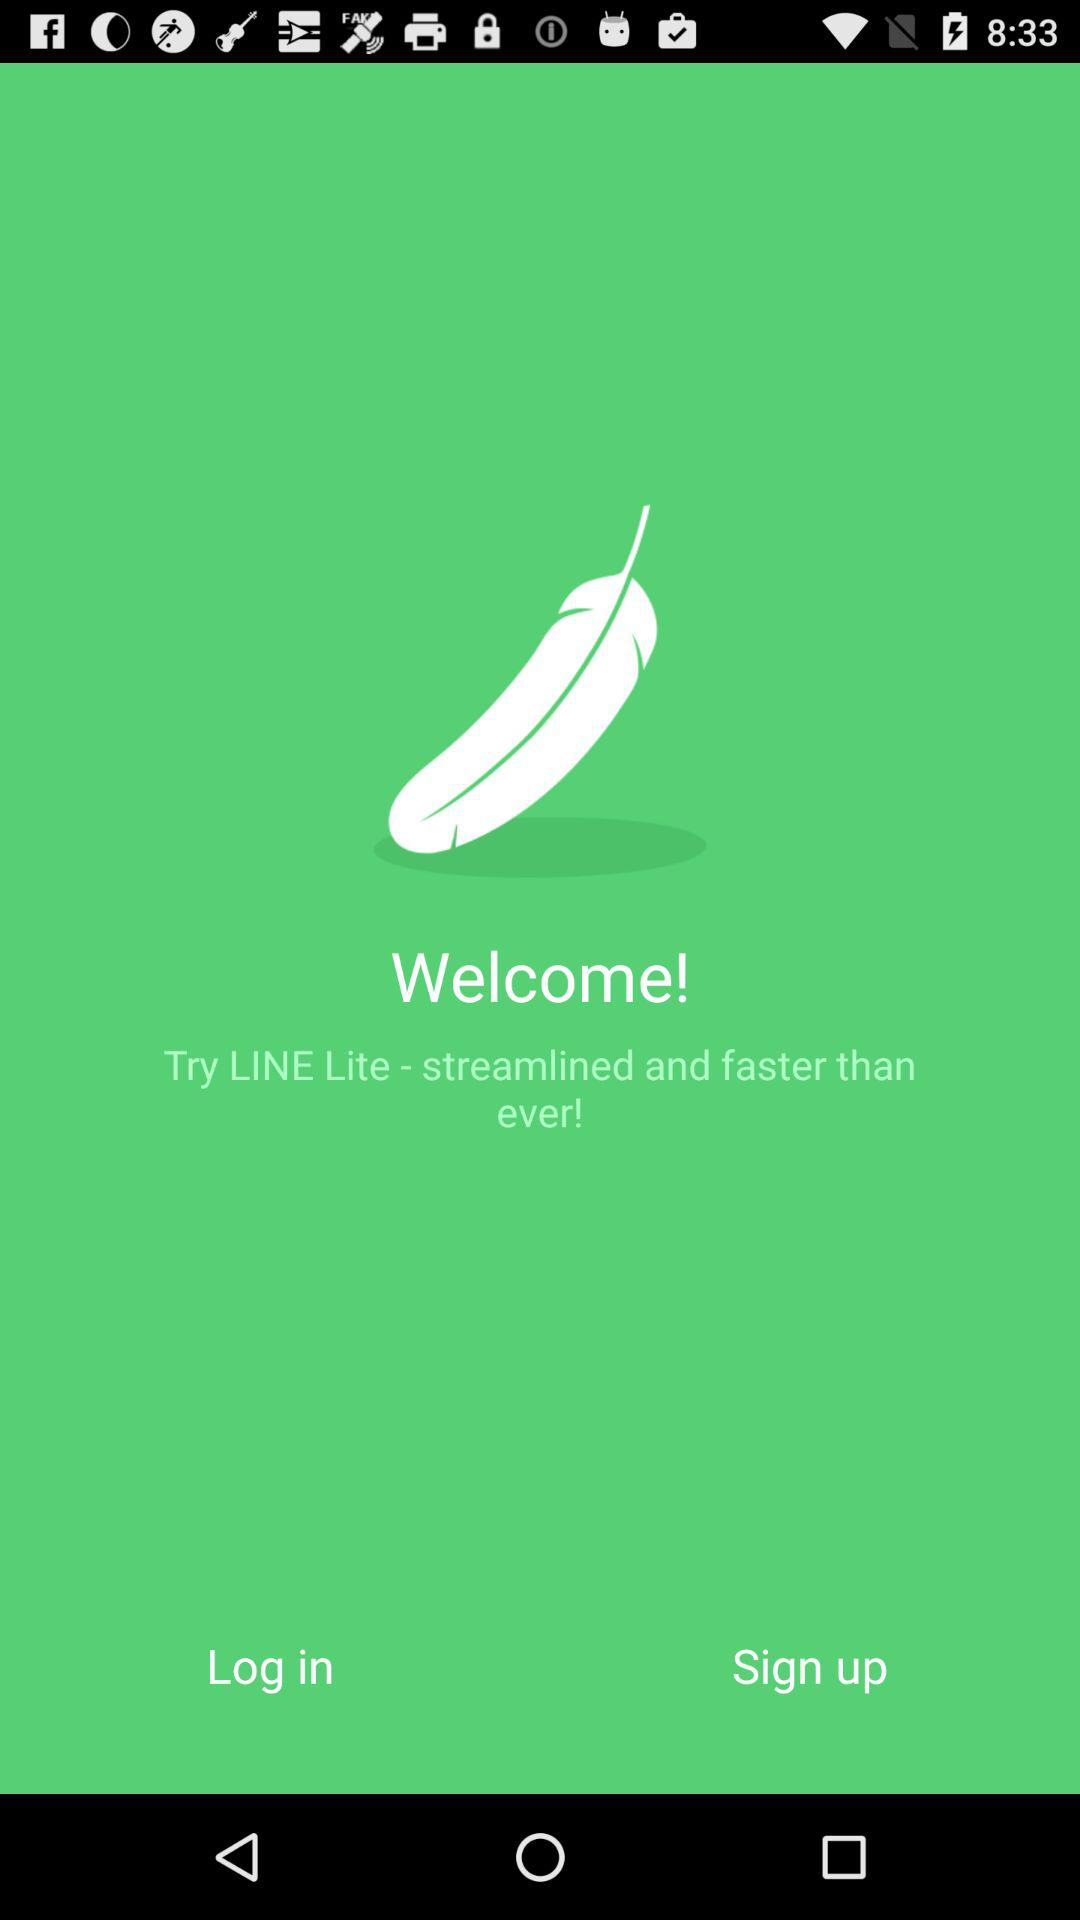What is the application name? The application name is "LINE Lite". 